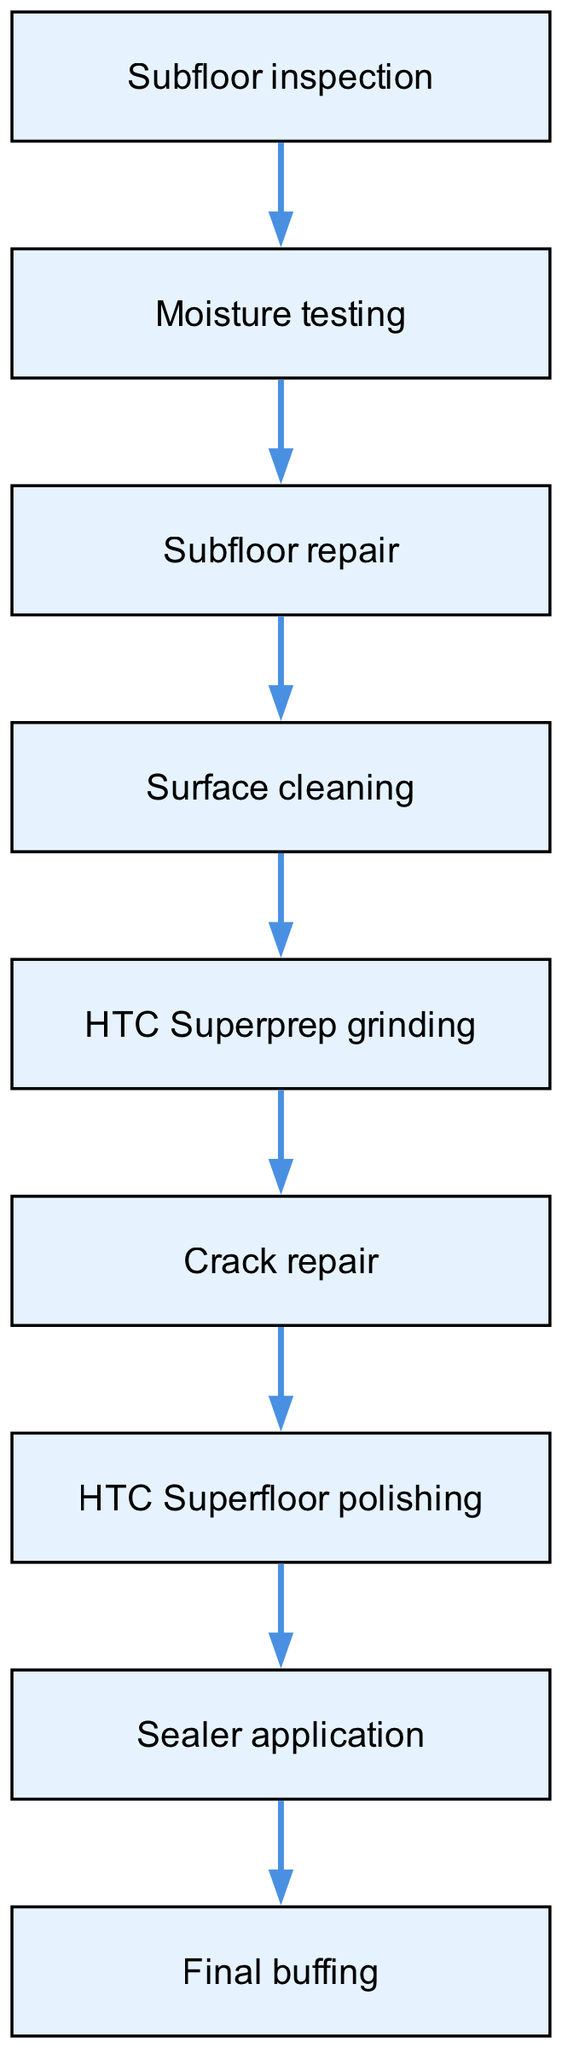What is the first step in the flooring installation process? The first step as shown in the diagram is "Subfloor inspection." Each node represents a step in the process, and "Subfloor inspection" is positioned at the top, indicating it is the starting point.
Answer: Subfloor inspection How many nodes are there in the diagram? The total number of nodes listed in the diagram is nine. I counted each unique step from the beginning through to the end, ensuring I accounted for all nodes present.
Answer: Nine Which node follows "Surface cleaning"? The node that follows "Surface cleaning" is "HTC Superprep grinding." By following the directed edges from this node, we can see that it directly leads to the next step in the process.
Answer: HTC Superprep grinding What step comes before "Sealer application"? The step that comes before "Sealer application" is "HTC Superfloor polishing." Tracing the edges leading to "Sealer application," this is the immediately preceding step in the workflow.
Answer: HTC Superfloor polishing How many edges are present in the diagram? There are eight edges in the diagram. I counted each directed connection between the nodes, which reflects the flow from one step to the next, verifying it from the edges data.
Answer: Eight What process step occurs after "Crack repair"? The process step that occurs after "Crack repair" is "HTC Superfloor polishing." The directed edge from "Crack repair" to "HTC Superfloor polishing" shows the order of operations clearly.
Answer: HTC Superfloor polishing Which node is the final step in the flooring installation process? The final step in the flooring installation process is "Final buffing." It is positioned at the end of the flow in the diagram, indicating that it is the last procedure to be executed.
Answer: Final buffing If "Moisture testing" shows high levels, what is the next step? If "Moisture testing" shows high levels, the next step is "Subfloor repair." This is indicated by the directed edge that flows from "Moisture testing" to "Subfloor repair," suggesting that action must be taken before proceeding.
Answer: Subfloor repair 